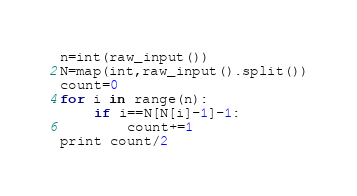<code> <loc_0><loc_0><loc_500><loc_500><_Python_>n=int(raw_input())
N=map(int,raw_input().split())
count=0
for i in range(n):
	if i==N[N[i]-1]-1:
		count+=1
print count/2
</code> 